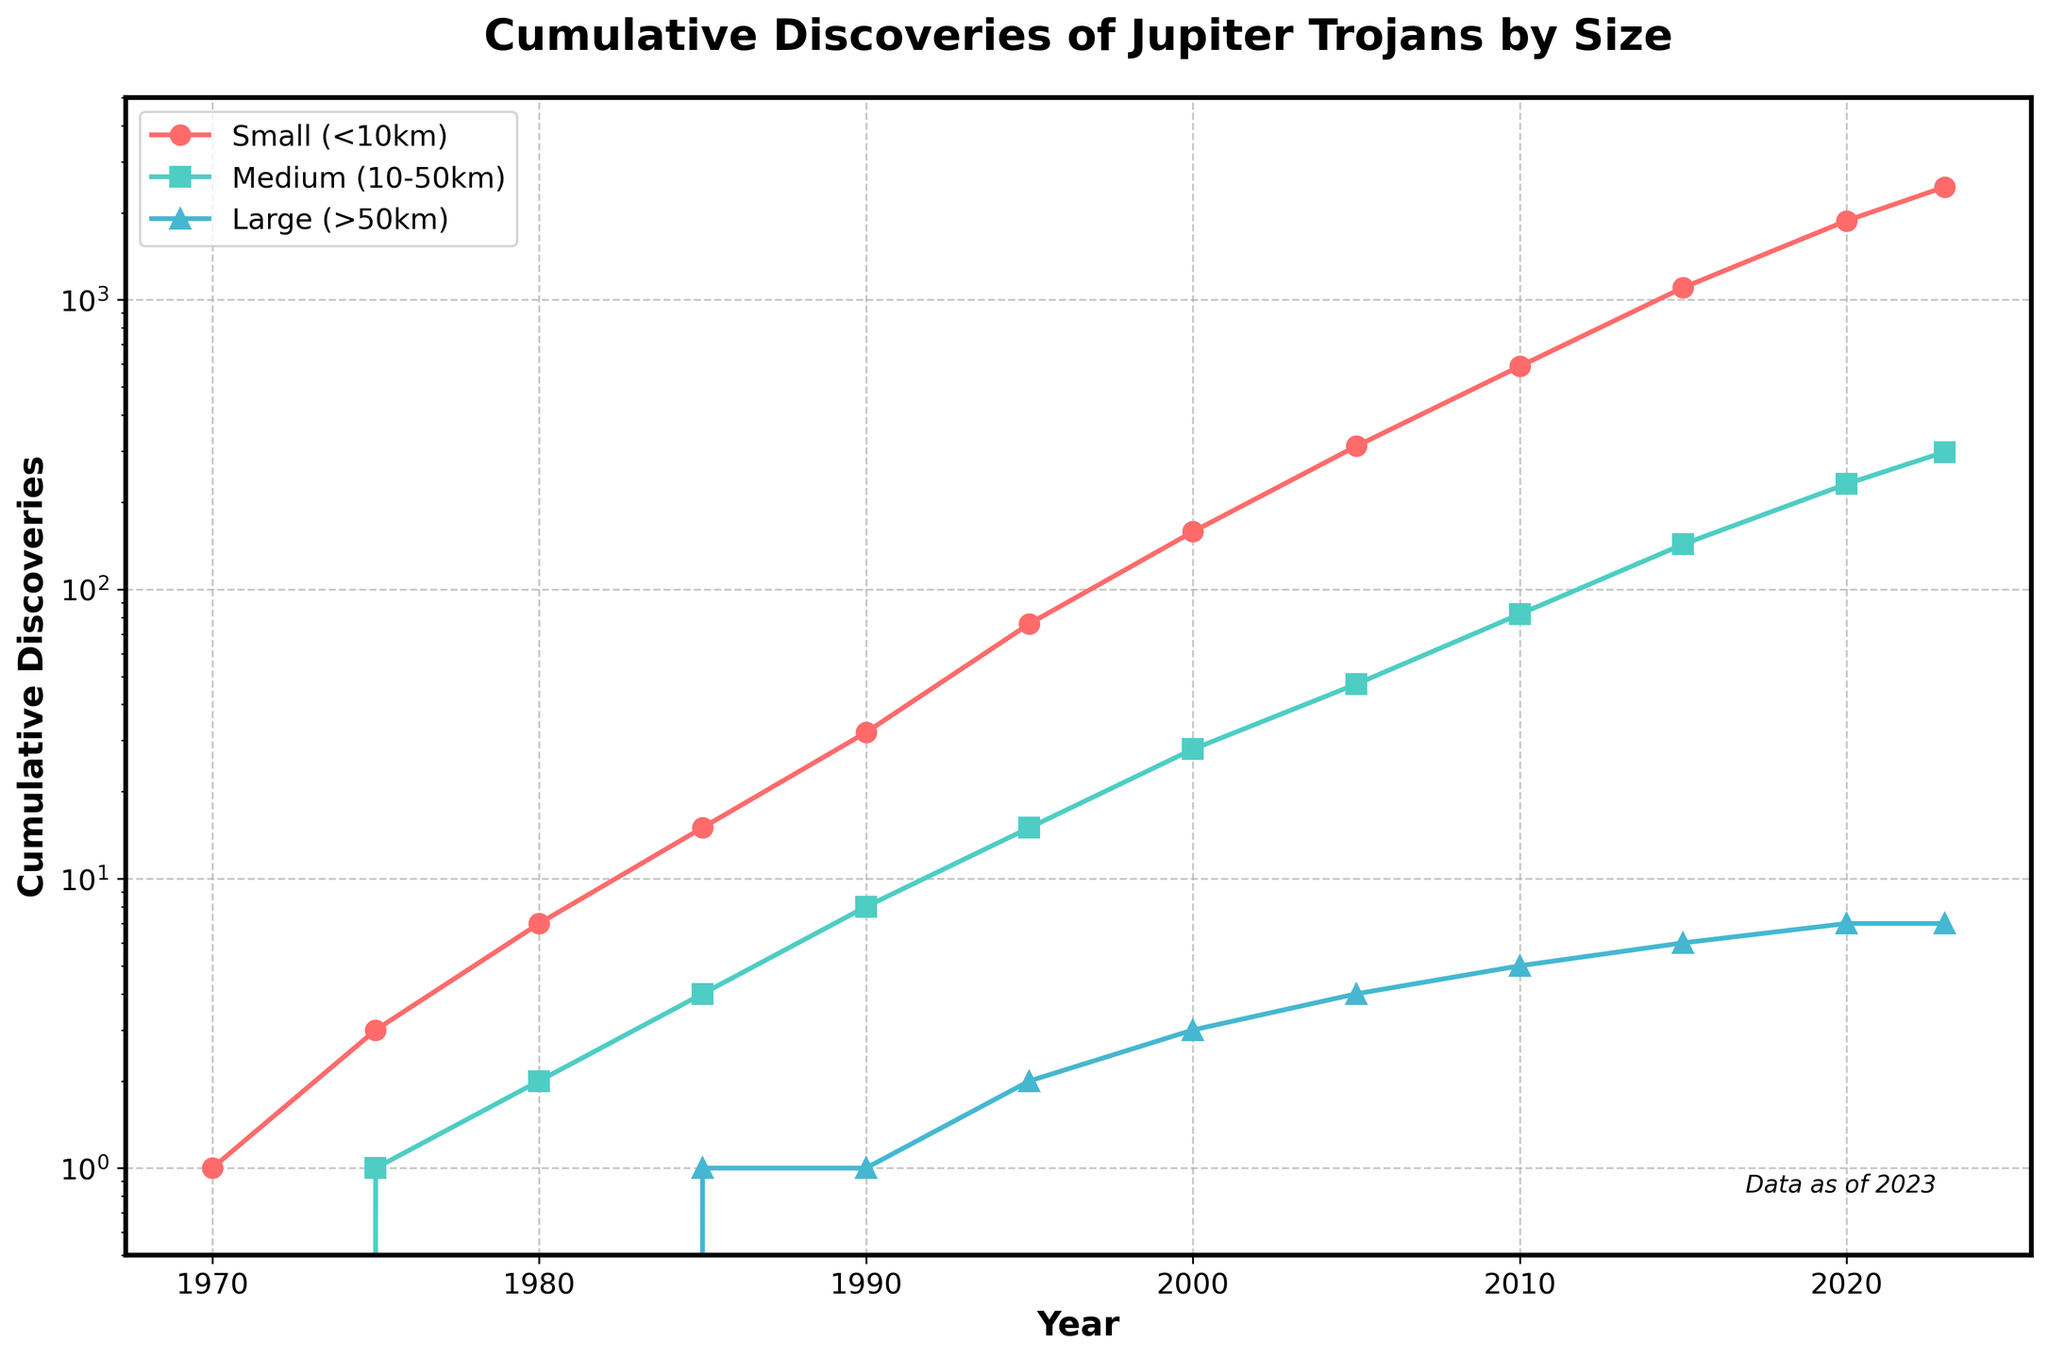What's the total number of Jupiter Trojans discovered by 2023? To find the total, sum the cumulative discoveries from all sizes for the year 2023: 2453 (small) + 298 (medium) + 7 (large) = 2758
Answer: 2758 During which period did the number of small Jupiter Trojans increase the most? The steepest increase can be identified by comparing the slope of the lines in the plot. The largest increase occurs between 2010 and 2015, with an increase from 589 to 1102.
Answer: 2010-2015 Are there more small or medium Jupiter Trojans discovered by 2020? Look at the values for 2020: small Jupiter Trojans are at 1876, while medium is at 231. Therefore, small Jupiter Trojans are more.
Answer: Small By how much did the number of large Jupiter Trojans increase between 1985 and 1995? For 1985, the number is 1, and for 1995, it is 2. The increase is 2 - 1 = 1
Answer: 1 In which year did the cumulative discoveries of medium Jupiter Trojans surpass 100? Analyze the plot and look for when the medium Jupiter Trojans exceed 100. This happens around 2010 when they reach 143.
Answer: 2010 At what year did the number of small Jupiter Trojans first reach or exceed 1000? Looking at the plot, this happens in 2015, when the discovery count for small Jupiter Trojans is at 1102.
Answer: 2015 What is the difference in cumulative discoveries between small and large Jupiter Trojans in 2023? For 2023, small is 2453 and large is 7. The difference is 2453 - 7 = 2446.
Answer: 2446 How does the growth rate of small Jupiter Trojans compare to that of large Jupiter Trojans from 1970 to 2023? Small Jupiter Trojans increased from 1 to 2453, while large increased from 0 to 7. The growth rate for small is significantly higher.
Answer: Small grows significantly faster What is the average increase in medium-sized Jupiter Trojans per year between 2000 and 2023? The increase is 298 - 28 = 270, and the number of years is 2023 - 2000 = 23. So, the average increase per year is 270 / 23 ≈ 11.74
Answer: 11.74 Which size category of Jupiter Trojans shows a logarithmic growth pattern? The small (<10km) category shows a steady logarithmic increase over the years, as evident from the consistent curvature in a log-scaled y-axis.
Answer: Small (<10km) 